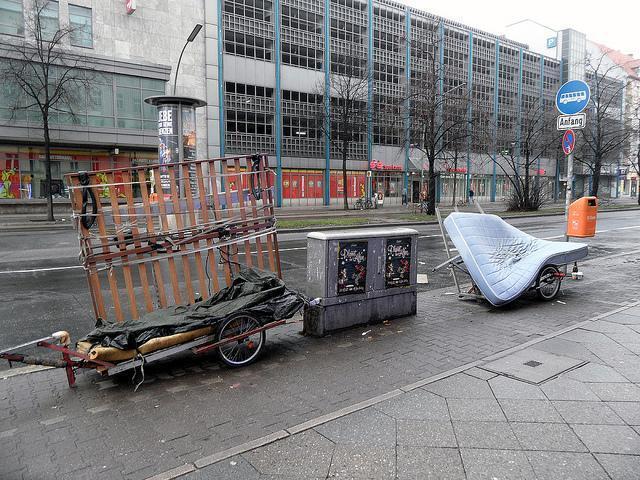How many trailers are there?
Give a very brief answer. 2. How many boats can be seen in this image?
Give a very brief answer. 0. 